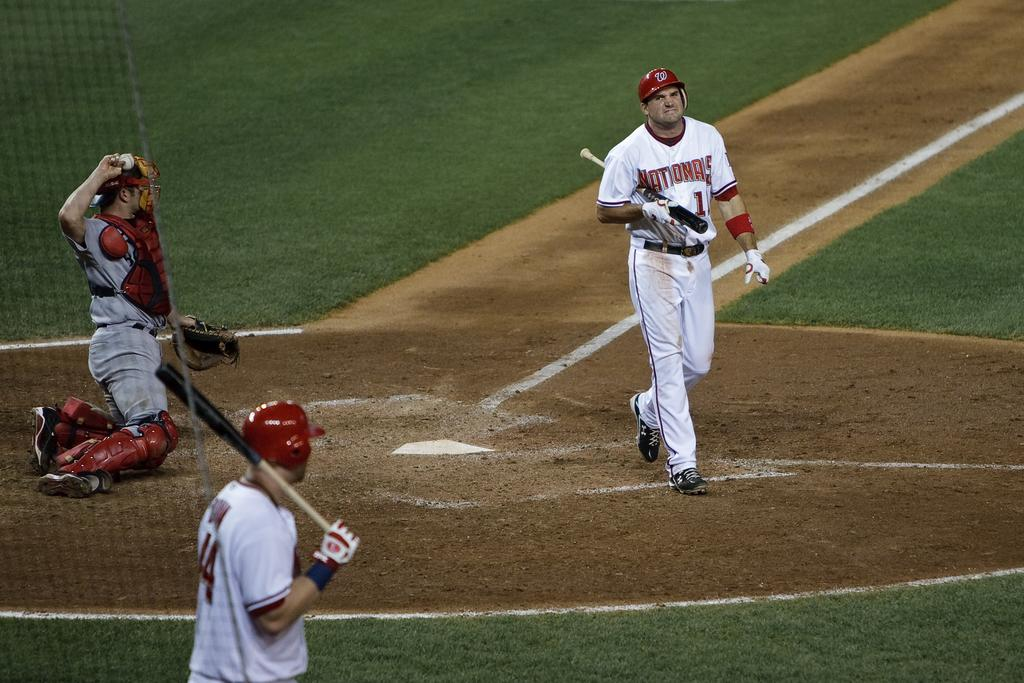Provide a one-sentence caption for the provided image. Number 1 for the Nationals walks away from the plate with a disappointed look on his face. 